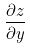<formula> <loc_0><loc_0><loc_500><loc_500>\frac { \partial z } { \partial y }</formula> 